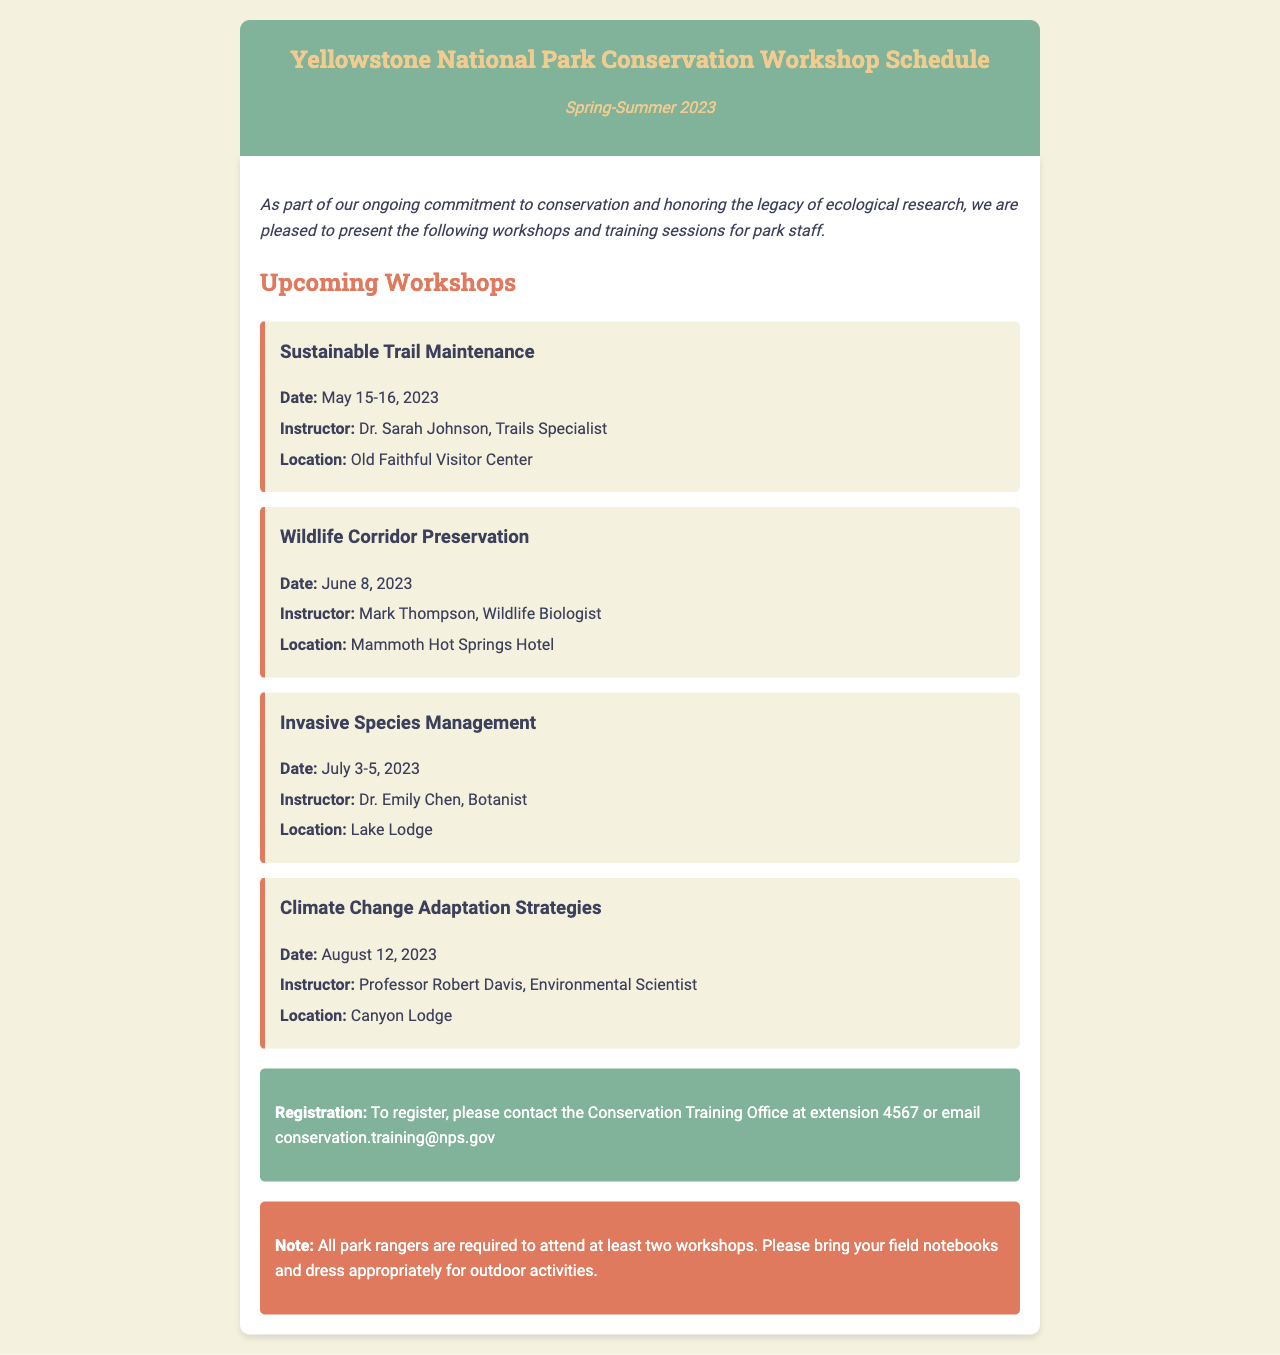what is the date of the Sustainable Trail Maintenance workshop? The date for the Sustainable Trail Maintenance workshop is mentioned as May 15-16, 2023.
Answer: May 15-16, 2023 who is the instructor for the Wildlife Corridor Preservation workshop? The document states that the instructor for the Wildlife Corridor Preservation workshop is Mark Thompson.
Answer: Mark Thompson where will the Invasive Species Management workshop take place? The location for the Invasive Species Management workshop is specified as Lake Lodge in the document.
Answer: Lake Lodge how many workshops are park rangers required to attend? It is indicated in the note that all park rangers are required to attend at least two workshops.
Answer: two what type of training does the note suggest to bring? The note advises participants to bring their field notebooks for the workshops.
Answer: field notebooks which workshop is focused on climate change? The workshop focused on climate change adaptation strategies is titled Climate Change Adaptation Strategies.
Answer: Climate Change Adaptation Strategies when is the session on Wildlife Corridor Preservation scheduled? The schedule for the Wildlife Corridor Preservation workshop is on June 8, 2023.
Answer: June 8, 2023 what is the contact method for registration? The registration section notes that staff can register by contacting the Conservation Training Office or emailing conservation.training@nps.gov.
Answer: email conservation.training@nps.gov 